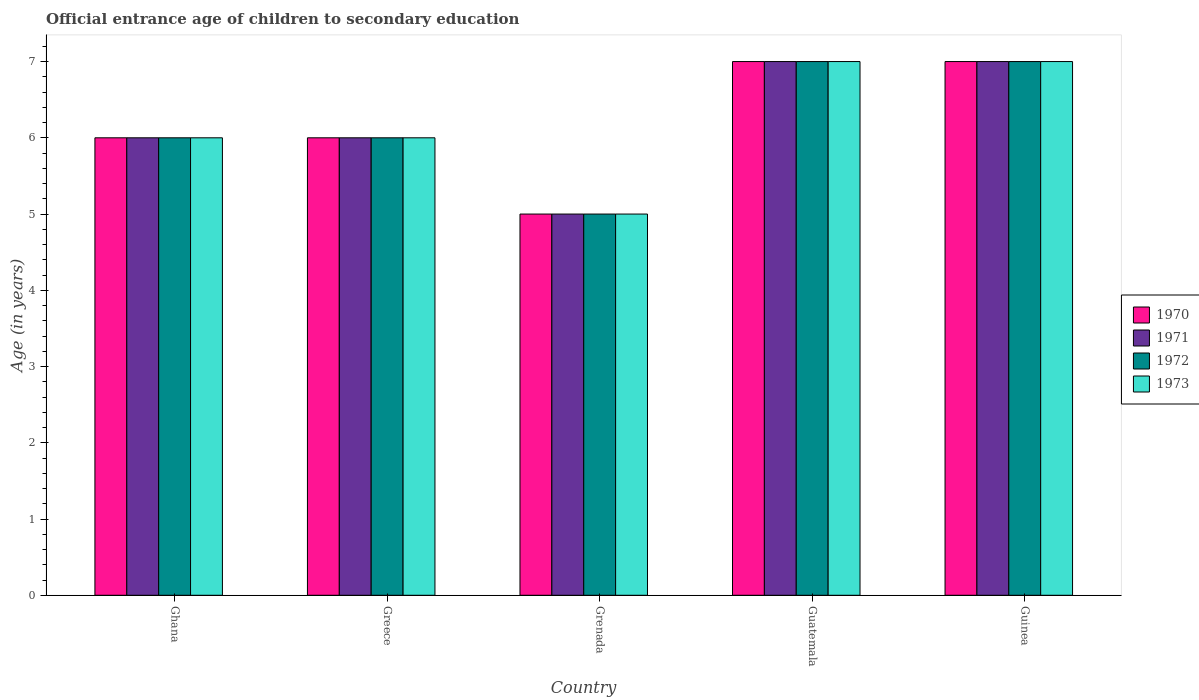How many different coloured bars are there?
Ensure brevity in your answer.  4. How many groups of bars are there?
Keep it short and to the point. 5. Are the number of bars per tick equal to the number of legend labels?
Your response must be concise. Yes. How many bars are there on the 2nd tick from the left?
Keep it short and to the point. 4. Across all countries, what is the maximum secondary school starting age of children in 1971?
Provide a succinct answer. 7. In which country was the secondary school starting age of children in 1970 maximum?
Offer a very short reply. Guatemala. In which country was the secondary school starting age of children in 1973 minimum?
Keep it short and to the point. Grenada. What is the difference between the secondary school starting age of children in 1970 in Ghana and that in Grenada?
Keep it short and to the point. 1. In how many countries, is the secondary school starting age of children in 1973 greater than 5.8 years?
Your response must be concise. 4. What is the difference between the highest and the second highest secondary school starting age of children in 1973?
Offer a terse response. -1. In how many countries, is the secondary school starting age of children in 1971 greater than the average secondary school starting age of children in 1971 taken over all countries?
Make the answer very short. 2. Is it the case that in every country, the sum of the secondary school starting age of children in 1970 and secondary school starting age of children in 1971 is greater than the sum of secondary school starting age of children in 1973 and secondary school starting age of children in 1972?
Provide a short and direct response. No. Is it the case that in every country, the sum of the secondary school starting age of children in 1972 and secondary school starting age of children in 1971 is greater than the secondary school starting age of children in 1970?
Ensure brevity in your answer.  Yes. How many bars are there?
Provide a succinct answer. 20. What is the difference between two consecutive major ticks on the Y-axis?
Offer a very short reply. 1. Does the graph contain grids?
Offer a terse response. No. Where does the legend appear in the graph?
Offer a terse response. Center right. How many legend labels are there?
Provide a succinct answer. 4. How are the legend labels stacked?
Make the answer very short. Vertical. What is the title of the graph?
Offer a very short reply. Official entrance age of children to secondary education. Does "1992" appear as one of the legend labels in the graph?
Ensure brevity in your answer.  No. What is the label or title of the Y-axis?
Your answer should be compact. Age (in years). What is the Age (in years) of 1971 in Ghana?
Your answer should be very brief. 6. What is the Age (in years) in 1972 in Ghana?
Give a very brief answer. 6. What is the Age (in years) of 1973 in Ghana?
Keep it short and to the point. 6. What is the Age (in years) of 1970 in Greece?
Keep it short and to the point. 6. What is the Age (in years) in 1971 in Greece?
Ensure brevity in your answer.  6. What is the Age (in years) in 1970 in Grenada?
Provide a short and direct response. 5. What is the Age (in years) of 1970 in Guatemala?
Provide a succinct answer. 7. What is the Age (in years) in 1971 in Guatemala?
Offer a very short reply. 7. What is the Age (in years) of 1973 in Guatemala?
Keep it short and to the point. 7. What is the Age (in years) in 1973 in Guinea?
Make the answer very short. 7. Across all countries, what is the maximum Age (in years) in 1971?
Provide a succinct answer. 7. Across all countries, what is the minimum Age (in years) of 1970?
Make the answer very short. 5. Across all countries, what is the minimum Age (in years) in 1972?
Provide a succinct answer. 5. What is the total Age (in years) of 1971 in the graph?
Provide a succinct answer. 31. What is the total Age (in years) in 1973 in the graph?
Offer a very short reply. 31. What is the difference between the Age (in years) in 1971 in Ghana and that in Greece?
Provide a short and direct response. 0. What is the difference between the Age (in years) of 1972 in Ghana and that in Greece?
Offer a terse response. 0. What is the difference between the Age (in years) of 1970 in Ghana and that in Grenada?
Your answer should be compact. 1. What is the difference between the Age (in years) in 1971 in Ghana and that in Grenada?
Make the answer very short. 1. What is the difference between the Age (in years) of 1972 in Ghana and that in Grenada?
Provide a succinct answer. 1. What is the difference between the Age (in years) of 1970 in Ghana and that in Guatemala?
Your response must be concise. -1. What is the difference between the Age (in years) of 1971 in Ghana and that in Guatemala?
Give a very brief answer. -1. What is the difference between the Age (in years) of 1972 in Ghana and that in Guatemala?
Ensure brevity in your answer.  -1. What is the difference between the Age (in years) in 1972 in Greece and that in Grenada?
Offer a very short reply. 1. What is the difference between the Age (in years) of 1971 in Greece and that in Guatemala?
Provide a short and direct response. -1. What is the difference between the Age (in years) in 1972 in Greece and that in Guatemala?
Offer a terse response. -1. What is the difference between the Age (in years) in 1973 in Greece and that in Guatemala?
Your answer should be very brief. -1. What is the difference between the Age (in years) in 1970 in Greece and that in Guinea?
Your answer should be compact. -1. What is the difference between the Age (in years) of 1971 in Greece and that in Guinea?
Ensure brevity in your answer.  -1. What is the difference between the Age (in years) of 1972 in Greece and that in Guinea?
Provide a succinct answer. -1. What is the difference between the Age (in years) in 1972 in Grenada and that in Guatemala?
Give a very brief answer. -2. What is the difference between the Age (in years) in 1973 in Grenada and that in Guatemala?
Keep it short and to the point. -2. What is the difference between the Age (in years) of 1970 in Grenada and that in Guinea?
Keep it short and to the point. -2. What is the difference between the Age (in years) in 1971 in Grenada and that in Guinea?
Keep it short and to the point. -2. What is the difference between the Age (in years) in 1972 in Grenada and that in Guinea?
Make the answer very short. -2. What is the difference between the Age (in years) of 1973 in Grenada and that in Guinea?
Keep it short and to the point. -2. What is the difference between the Age (in years) of 1971 in Guatemala and that in Guinea?
Provide a succinct answer. 0. What is the difference between the Age (in years) of 1972 in Guatemala and that in Guinea?
Give a very brief answer. 0. What is the difference between the Age (in years) of 1973 in Guatemala and that in Guinea?
Make the answer very short. 0. What is the difference between the Age (in years) in 1970 in Ghana and the Age (in years) in 1971 in Greece?
Keep it short and to the point. 0. What is the difference between the Age (in years) of 1970 in Ghana and the Age (in years) of 1972 in Greece?
Offer a very short reply. 0. What is the difference between the Age (in years) of 1970 in Ghana and the Age (in years) of 1971 in Grenada?
Ensure brevity in your answer.  1. What is the difference between the Age (in years) in 1970 in Ghana and the Age (in years) in 1972 in Grenada?
Your response must be concise. 1. What is the difference between the Age (in years) in 1970 in Ghana and the Age (in years) in 1973 in Grenada?
Ensure brevity in your answer.  1. What is the difference between the Age (in years) in 1971 in Ghana and the Age (in years) in 1972 in Grenada?
Provide a succinct answer. 1. What is the difference between the Age (in years) in 1971 in Ghana and the Age (in years) in 1973 in Grenada?
Provide a short and direct response. 1. What is the difference between the Age (in years) of 1972 in Ghana and the Age (in years) of 1973 in Grenada?
Your response must be concise. 1. What is the difference between the Age (in years) of 1972 in Ghana and the Age (in years) of 1973 in Guatemala?
Offer a very short reply. -1. What is the difference between the Age (in years) in 1970 in Ghana and the Age (in years) in 1972 in Guinea?
Keep it short and to the point. -1. What is the difference between the Age (in years) of 1970 in Ghana and the Age (in years) of 1973 in Guinea?
Your answer should be compact. -1. What is the difference between the Age (in years) in 1971 in Ghana and the Age (in years) in 1972 in Guinea?
Offer a terse response. -1. What is the difference between the Age (in years) of 1970 in Greece and the Age (in years) of 1971 in Grenada?
Offer a very short reply. 1. What is the difference between the Age (in years) of 1971 in Greece and the Age (in years) of 1972 in Grenada?
Give a very brief answer. 1. What is the difference between the Age (in years) of 1971 in Greece and the Age (in years) of 1973 in Grenada?
Your answer should be very brief. 1. What is the difference between the Age (in years) in 1972 in Greece and the Age (in years) in 1973 in Grenada?
Ensure brevity in your answer.  1. What is the difference between the Age (in years) of 1970 in Greece and the Age (in years) of 1973 in Guatemala?
Offer a terse response. -1. What is the difference between the Age (in years) of 1971 in Greece and the Age (in years) of 1972 in Guatemala?
Keep it short and to the point. -1. What is the difference between the Age (in years) of 1970 in Greece and the Age (in years) of 1972 in Guinea?
Offer a terse response. -1. What is the difference between the Age (in years) of 1970 in Greece and the Age (in years) of 1973 in Guinea?
Offer a terse response. -1. What is the difference between the Age (in years) in 1970 in Grenada and the Age (in years) in 1971 in Guatemala?
Provide a succinct answer. -2. What is the difference between the Age (in years) of 1970 in Grenada and the Age (in years) of 1973 in Guatemala?
Offer a terse response. -2. What is the difference between the Age (in years) of 1971 in Grenada and the Age (in years) of 1972 in Guatemala?
Provide a succinct answer. -2. What is the difference between the Age (in years) of 1971 in Grenada and the Age (in years) of 1973 in Guatemala?
Provide a succinct answer. -2. What is the difference between the Age (in years) in 1972 in Grenada and the Age (in years) in 1973 in Guatemala?
Make the answer very short. -2. What is the difference between the Age (in years) in 1970 in Grenada and the Age (in years) in 1971 in Guinea?
Your answer should be very brief. -2. What is the difference between the Age (in years) in 1970 in Grenada and the Age (in years) in 1973 in Guinea?
Offer a terse response. -2. What is the difference between the Age (in years) in 1971 in Grenada and the Age (in years) in 1972 in Guinea?
Offer a very short reply. -2. What is the difference between the Age (in years) of 1970 in Guatemala and the Age (in years) of 1972 in Guinea?
Provide a succinct answer. 0. What is the difference between the Age (in years) of 1971 in Guatemala and the Age (in years) of 1972 in Guinea?
Provide a succinct answer. 0. What is the difference between the Age (in years) in 1971 in Guatemala and the Age (in years) in 1973 in Guinea?
Your answer should be compact. 0. What is the difference between the Age (in years) in 1972 in Guatemala and the Age (in years) in 1973 in Guinea?
Give a very brief answer. 0. What is the difference between the Age (in years) of 1970 and Age (in years) of 1971 in Ghana?
Offer a very short reply. 0. What is the difference between the Age (in years) in 1970 and Age (in years) in 1972 in Ghana?
Provide a succinct answer. 0. What is the difference between the Age (in years) in 1971 and Age (in years) in 1972 in Ghana?
Provide a succinct answer. 0. What is the difference between the Age (in years) of 1972 and Age (in years) of 1973 in Ghana?
Your answer should be very brief. 0. What is the difference between the Age (in years) in 1970 and Age (in years) in 1971 in Greece?
Make the answer very short. 0. What is the difference between the Age (in years) in 1970 and Age (in years) in 1973 in Greece?
Your answer should be compact. 0. What is the difference between the Age (in years) in 1970 and Age (in years) in 1971 in Grenada?
Your answer should be compact. 0. What is the difference between the Age (in years) of 1970 and Age (in years) of 1972 in Grenada?
Your answer should be very brief. 0. What is the difference between the Age (in years) of 1971 and Age (in years) of 1973 in Grenada?
Your response must be concise. 0. What is the difference between the Age (in years) of 1972 and Age (in years) of 1973 in Grenada?
Give a very brief answer. 0. What is the difference between the Age (in years) in 1970 and Age (in years) in 1973 in Guatemala?
Provide a short and direct response. 0. What is the difference between the Age (in years) of 1971 and Age (in years) of 1972 in Guatemala?
Make the answer very short. 0. What is the difference between the Age (in years) in 1971 and Age (in years) in 1973 in Guatemala?
Your response must be concise. 0. What is the difference between the Age (in years) in 1972 and Age (in years) in 1973 in Guatemala?
Your response must be concise. 0. What is the difference between the Age (in years) in 1971 and Age (in years) in 1973 in Guinea?
Provide a short and direct response. 0. What is the ratio of the Age (in years) in 1971 in Ghana to that in Greece?
Offer a terse response. 1. What is the ratio of the Age (in years) of 1970 in Ghana to that in Grenada?
Give a very brief answer. 1.2. What is the ratio of the Age (in years) in 1971 in Ghana to that in Grenada?
Your answer should be very brief. 1.2. What is the ratio of the Age (in years) of 1972 in Ghana to that in Grenada?
Offer a terse response. 1.2. What is the ratio of the Age (in years) in 1973 in Ghana to that in Grenada?
Offer a very short reply. 1.2. What is the ratio of the Age (in years) in 1971 in Ghana to that in Guatemala?
Give a very brief answer. 0.86. What is the ratio of the Age (in years) in 1971 in Ghana to that in Guinea?
Keep it short and to the point. 0.86. What is the ratio of the Age (in years) of 1970 in Greece to that in Grenada?
Provide a succinct answer. 1.2. What is the ratio of the Age (in years) of 1971 in Greece to that in Grenada?
Your response must be concise. 1.2. What is the ratio of the Age (in years) in 1973 in Greece to that in Grenada?
Make the answer very short. 1.2. What is the ratio of the Age (in years) in 1970 in Greece to that in Guatemala?
Offer a terse response. 0.86. What is the ratio of the Age (in years) of 1971 in Greece to that in Guatemala?
Keep it short and to the point. 0.86. What is the ratio of the Age (in years) of 1973 in Greece to that in Guatemala?
Your answer should be very brief. 0.86. What is the ratio of the Age (in years) of 1970 in Greece to that in Guinea?
Provide a succinct answer. 0.86. What is the ratio of the Age (in years) in 1971 in Greece to that in Guinea?
Keep it short and to the point. 0.86. What is the ratio of the Age (in years) of 1972 in Greece to that in Guinea?
Ensure brevity in your answer.  0.86. What is the ratio of the Age (in years) in 1971 in Grenada to that in Guatemala?
Ensure brevity in your answer.  0.71. What is the ratio of the Age (in years) in 1972 in Grenada to that in Guatemala?
Your answer should be very brief. 0.71. What is the ratio of the Age (in years) of 1973 in Grenada to that in Guatemala?
Offer a very short reply. 0.71. What is the ratio of the Age (in years) in 1970 in Grenada to that in Guinea?
Offer a very short reply. 0.71. What is the ratio of the Age (in years) of 1971 in Grenada to that in Guinea?
Ensure brevity in your answer.  0.71. What is the ratio of the Age (in years) of 1972 in Grenada to that in Guinea?
Provide a short and direct response. 0.71. What is the ratio of the Age (in years) in 1971 in Guatemala to that in Guinea?
Provide a succinct answer. 1. What is the ratio of the Age (in years) in 1973 in Guatemala to that in Guinea?
Offer a terse response. 1. What is the difference between the highest and the second highest Age (in years) of 1971?
Offer a very short reply. 0. What is the difference between the highest and the second highest Age (in years) of 1972?
Your response must be concise. 0. What is the difference between the highest and the lowest Age (in years) of 1973?
Offer a very short reply. 2. 